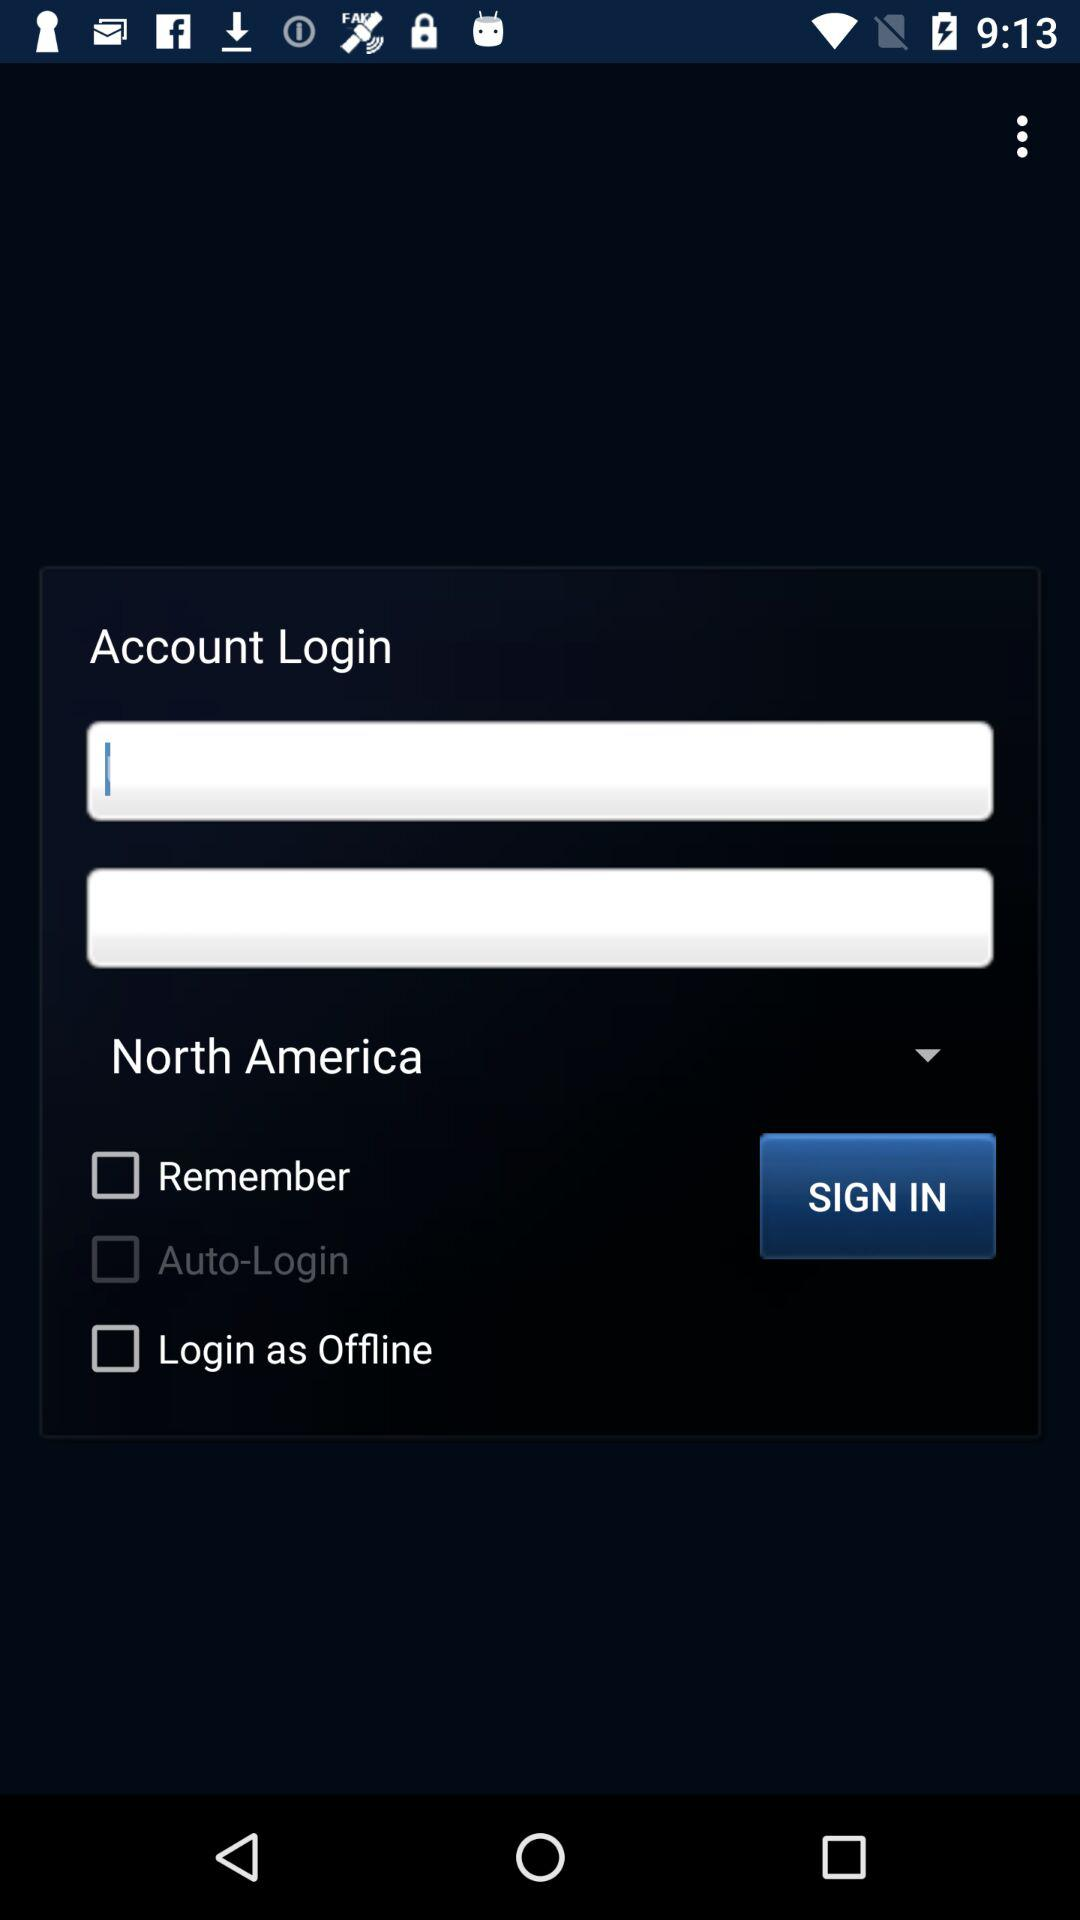What is the selected location? The selected location is North America. 